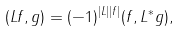Convert formula to latex. <formula><loc_0><loc_0><loc_500><loc_500>( L f , g ) = ( - 1 ) ^ { | L | | f | } ( f , L ^ { * } g ) ,</formula> 